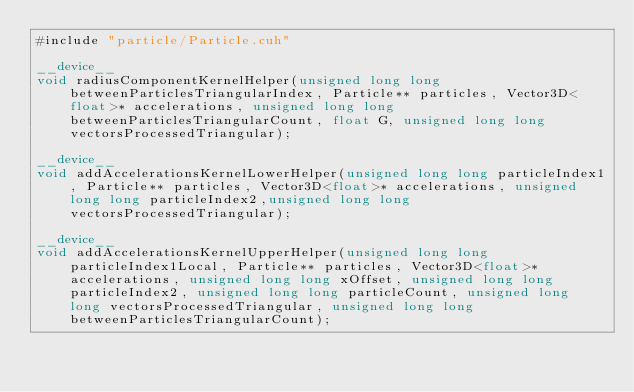<code> <loc_0><loc_0><loc_500><loc_500><_Cuda_>#include "particle/Particle.cuh"

__device__ 
void radiusComponentKernelHelper(unsigned long long betweenParticlesTriangularIndex, Particle** particles, Vector3D<float>* accelerations, unsigned long long betweenParticlesTriangularCount, float G, unsigned long long vectorsProcessedTriangular);

__device__ 
void addAccelerationsKernelLowerHelper(unsigned long long particleIndex1, Particle** particles, Vector3D<float>* accelerations, unsigned long long particleIndex2,unsigned long long vectorsProcessedTriangular);

__device__ 
void addAccelerationsKernelUpperHelper(unsigned long long particleIndex1Local, Particle** particles, Vector3D<float>* accelerations, unsigned long long xOffset, unsigned long long particleIndex2, unsigned long long particleCount, unsigned long long vectorsProcessedTriangular, unsigned long long betweenParticlesTriangularCount);
</code> 